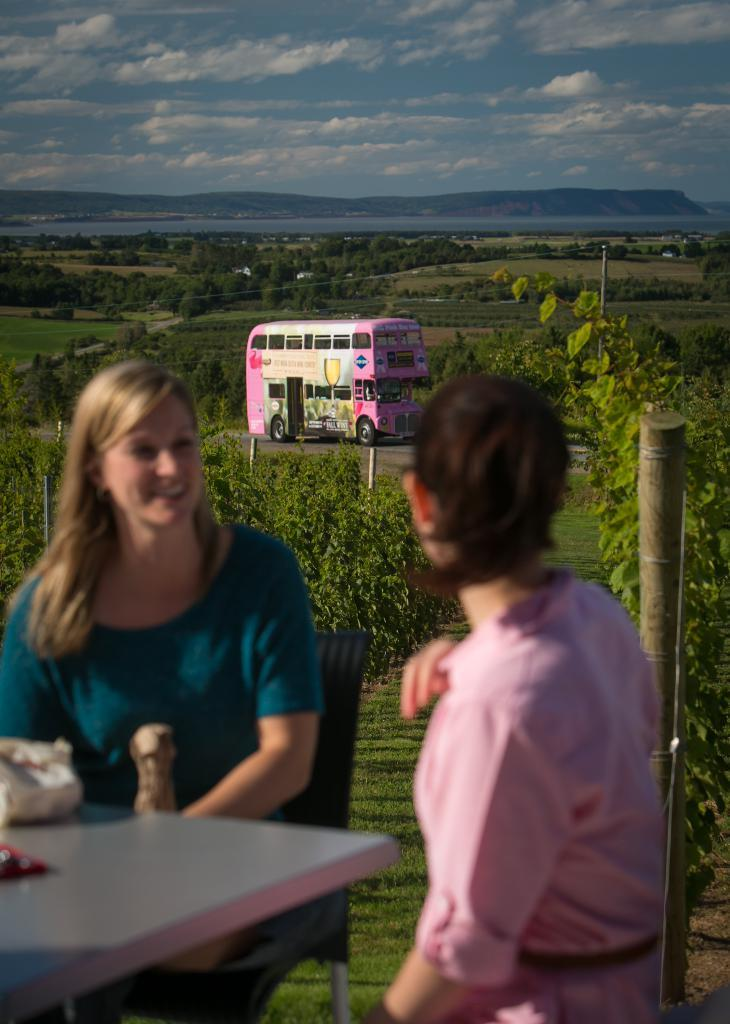How many women are in the image? There are two women in the image. What are the women doing? The women are sitting on chairs in the image. What is present in the image besides the women? There is a table in the image. What can be seen in the background of the image? There are trees in the background of the image. How would you describe the sky in the image? The sky is blue and cloudy in the image. What type of vessel can be seen sailing in the ocean in the image? There is no vessel or ocean present in the image; it features two women sitting on chairs, a table, trees, and a blue, cloudy sky. 